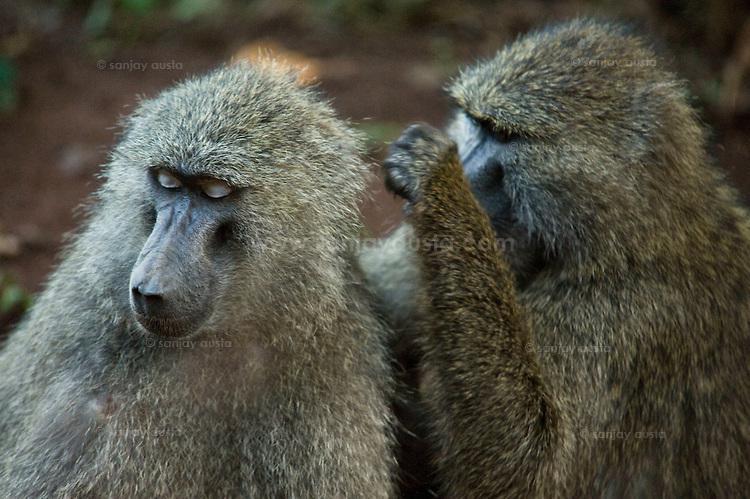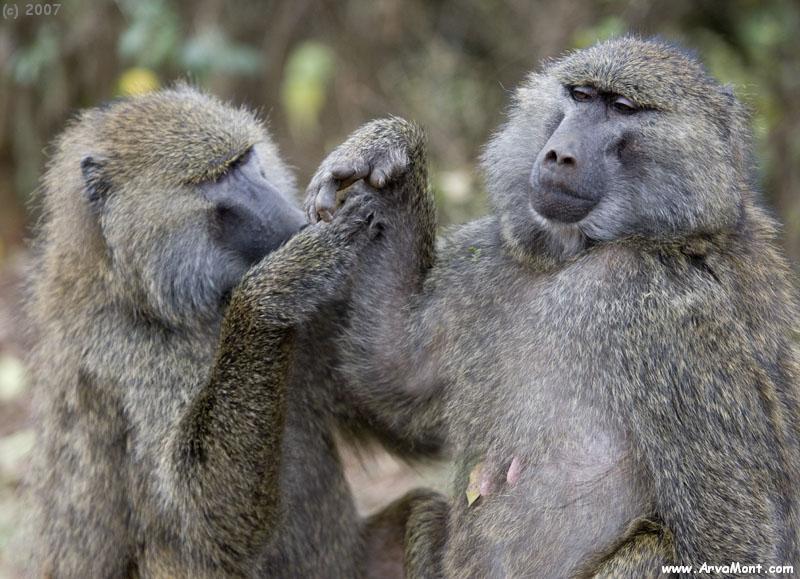The first image is the image on the left, the second image is the image on the right. Analyze the images presented: Is the assertion "In the image on the left, there are only 2 monkeys and they have their heads turned in the same direction." valid? Answer yes or no. Yes. 